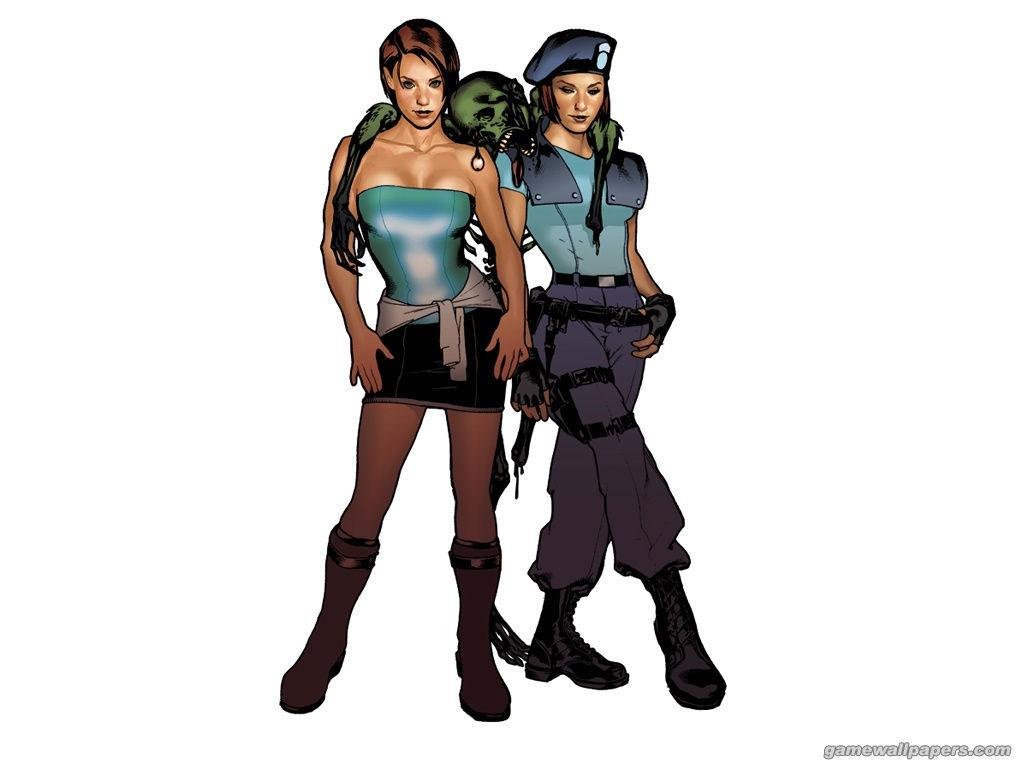What type of image is being described? The image is an animated picture. How many people are present in the image? There are two women in the image. What other character or object can be seen in the image? There is a skeleton in the image. Is there any additional information or branding present in the image? Yes, there is a watermark in the bottom right corner of the image. What type of rod is being used by the women in the image? There is no rod present in the image; it features two women and a skeleton in an animated picture. Can you describe the truck that is visible in the image? There is no truck present in the image; it only contains two women, a skeleton, and a watermark. 